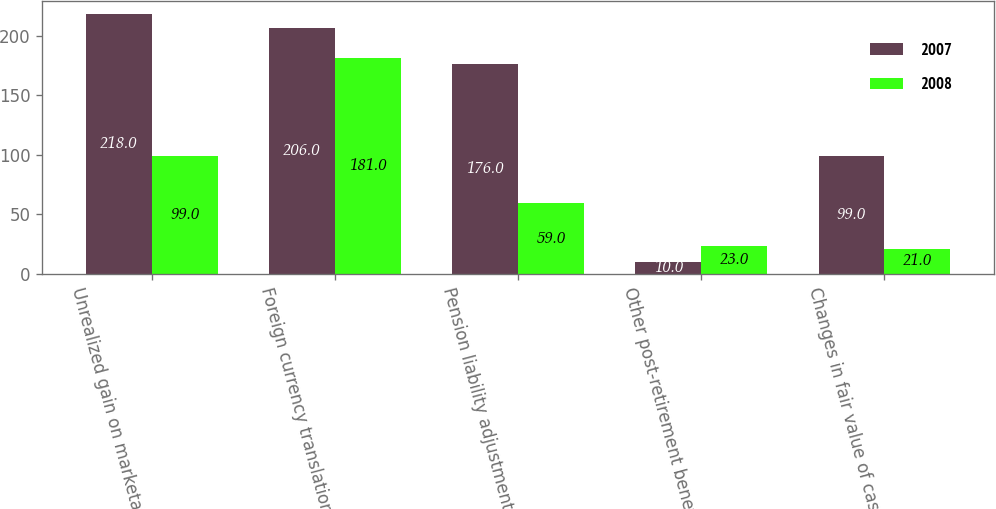Convert chart. <chart><loc_0><loc_0><loc_500><loc_500><stacked_bar_chart><ecel><fcel>Unrealized gain on marketable<fcel>Foreign currency translation<fcel>Pension liability adjustments<fcel>Other post-retirement benefit<fcel>Changes in fair value of cash<nl><fcel>2007<fcel>218<fcel>206<fcel>176<fcel>10<fcel>99<nl><fcel>2008<fcel>99<fcel>181<fcel>59<fcel>23<fcel>21<nl></chart> 